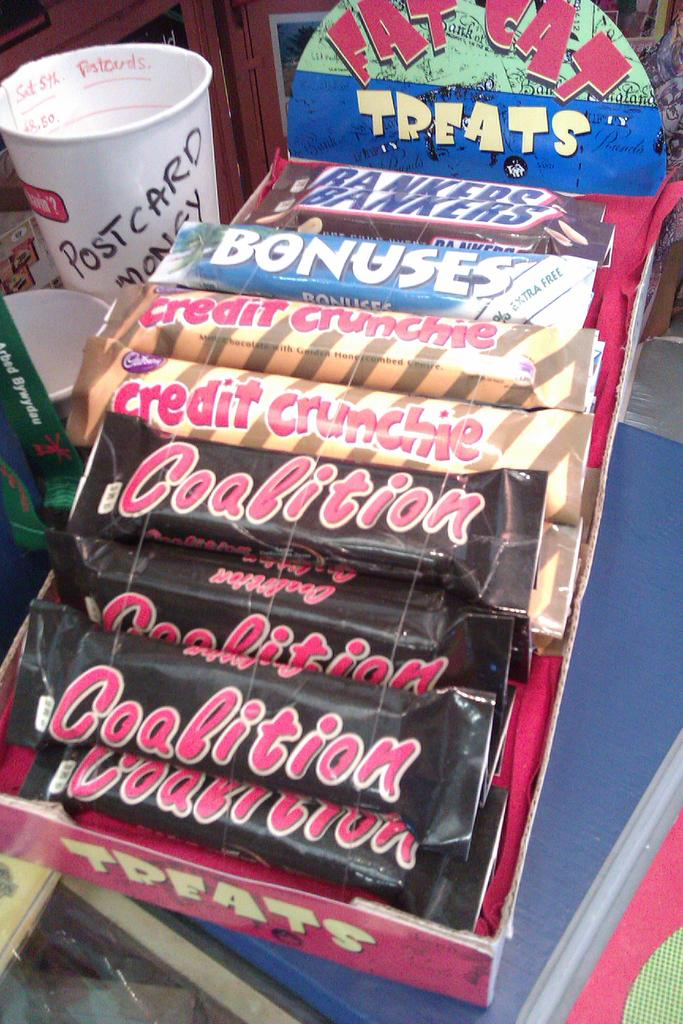What type of food is in the cardboard box in the image? There are chocolates in a cardboard box in the image. What type of cups are visible in the image? There are white cups visible in the image. Can you describe any other objects present in the image? There are other objects present in the image, but their specific details are not mentioned in the provided facts. What type of shoe is visible in the image? There is no shoe present in the image. What type of iron is used to make the chocolates in the image? There is no iron involved in the making of the chocolates in the image; they are simply in a cardboard box. 